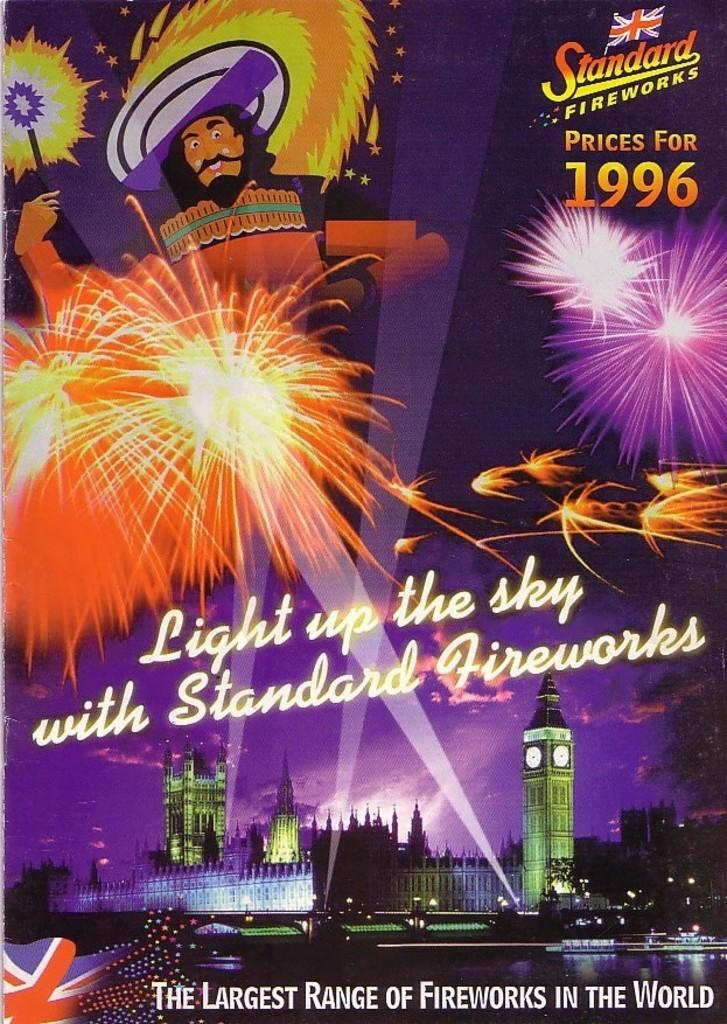<image>
Give a short and clear explanation of the subsequent image. an ad that had the year 1996 written on it 